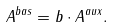<formula> <loc_0><loc_0><loc_500><loc_500>A ^ { b a s } = b \cdot A ^ { a u x } .</formula> 